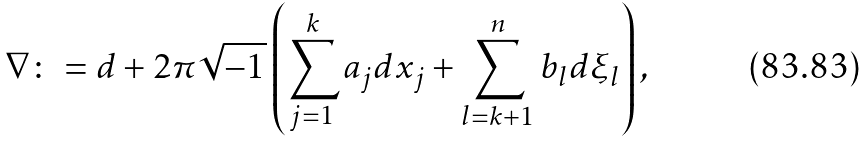Convert formula to latex. <formula><loc_0><loc_0><loc_500><loc_500>\nabla \colon = d + 2 \pi \sqrt { - 1 } \left ( \sum _ { j = 1 } ^ { k } a _ { j } d x _ { j } + \sum _ { l = k + 1 } ^ { n } b _ { l } d \xi _ { l } \right ) ,</formula> 